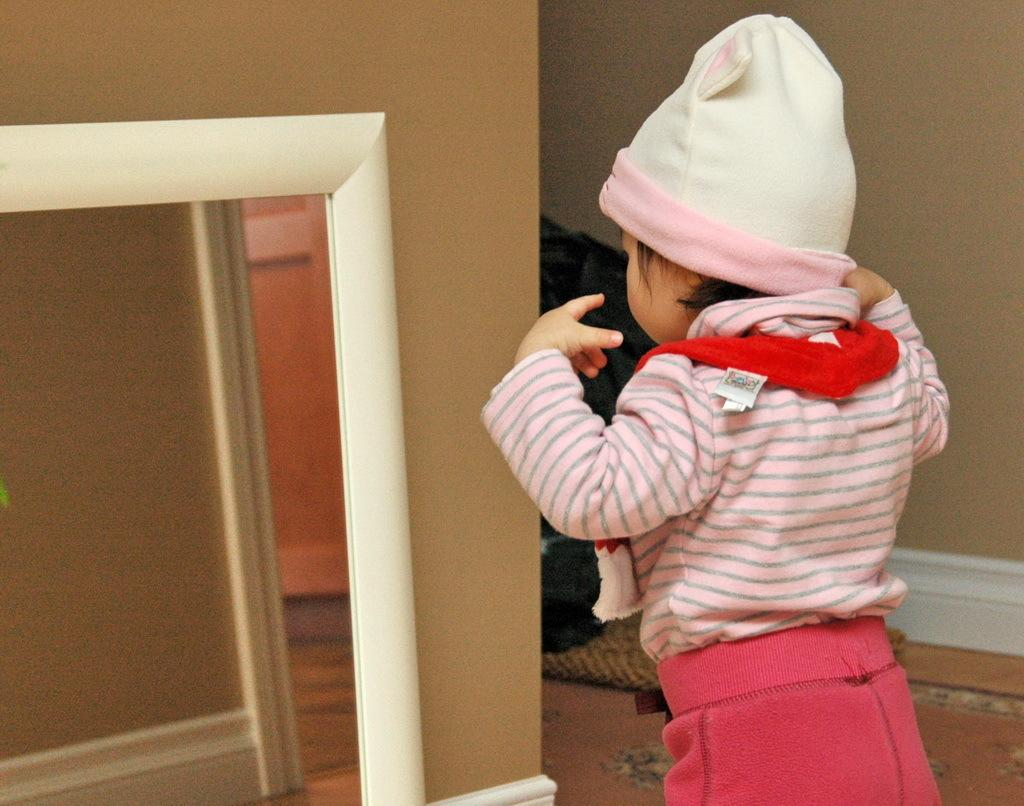What is the main subject of the image? There is a child standing in the image. What is in front of the child? There is a wall and a mirror in front of the child. What can be seen in the mirror? The mirror reflects the objects visible in front of the child. How many clovers can be seen growing in front of the child? There are no clovers visible in the image. Is there a bike leaning against the wall in front of the child? There is no bike present in the image. 